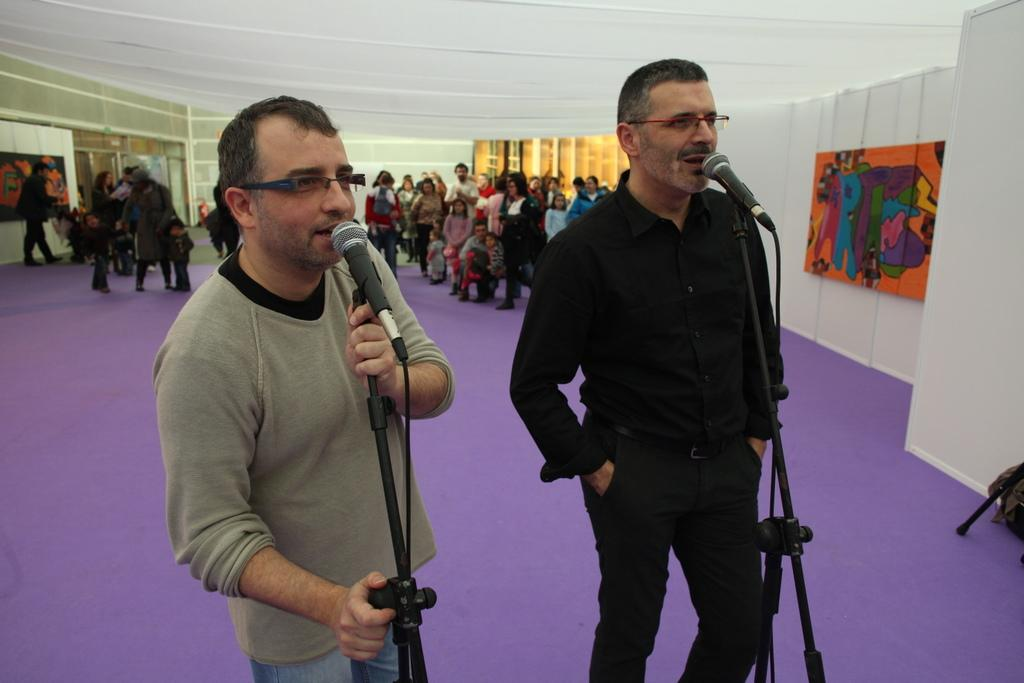What are the two men in the image doing? The two men are standing in front of a microphone. What can be seen on the wall in the image? There is a painting on the wall. Where are the majority of people located in the image? There is a crowd standing at the back. What type of hen can be seen sitting on the edge of the microphone in the image? There is no hen present in the image; it features two men standing in front of a microphone and a painting on the wall. 